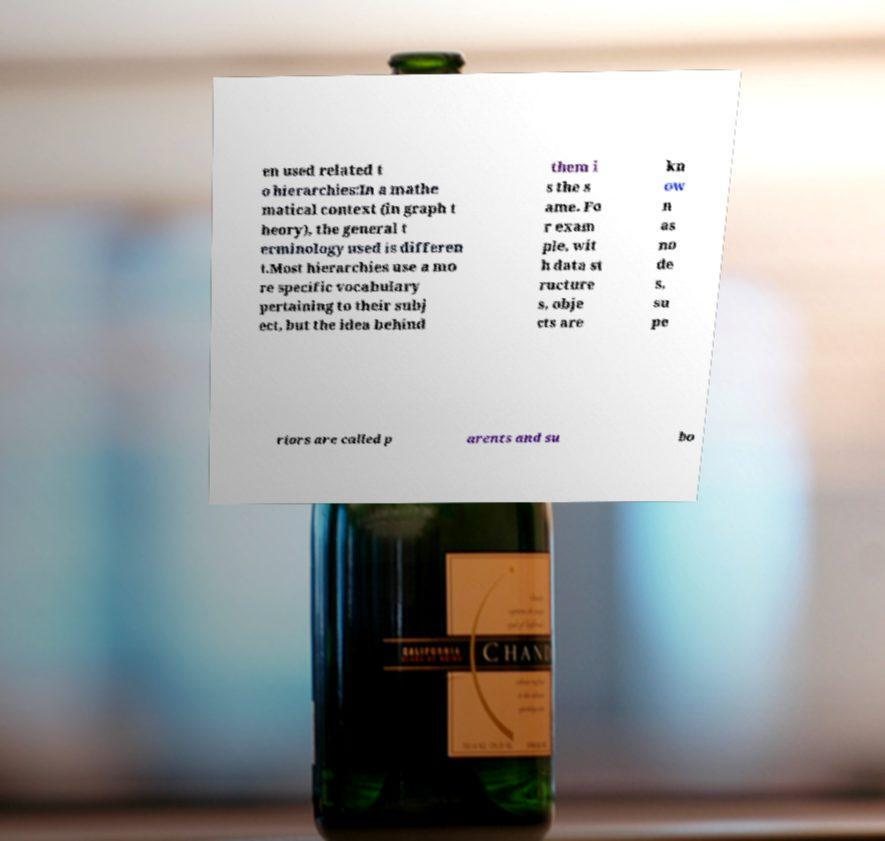What messages or text are displayed in this image? I need them in a readable, typed format. en used related t o hierarchies:In a mathe matical context (in graph t heory), the general t erminology used is differen t.Most hierarchies use a mo re specific vocabulary pertaining to their subj ect, but the idea behind them i s the s ame. Fo r exam ple, wit h data st ructure s, obje cts are kn ow n as no de s, su pe riors are called p arents and su bo 